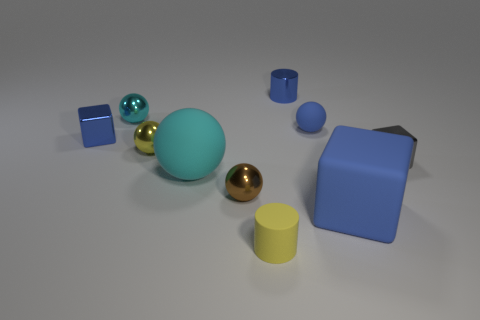There is a cyan thing in front of the tiny metal block left of the blue matte sphere behind the small brown ball; what is its size?
Your response must be concise. Large. What size is the rubber block that is the same color as the metal cylinder?
Give a very brief answer. Large. What is the material of the sphere that is the same color as the big block?
Your response must be concise. Rubber. Do the large rubber object that is behind the large blue matte block and the tiny metal ball behind the yellow ball have the same color?
Your answer should be compact. Yes. There is a cyan shiny thing on the left side of the big rubber thing that is on the right side of the tiny cylinder behind the large blue matte thing; what shape is it?
Offer a very short reply. Sphere. What shape is the blue thing that is both to the left of the tiny blue ball and right of the cyan metallic object?
Provide a short and direct response. Cylinder. What number of small yellow metallic things are in front of the tiny block that is to the right of the cylinder behind the cyan rubber sphere?
Provide a succinct answer. 0. There is a brown object that is the same shape as the small cyan metal thing; what size is it?
Provide a short and direct response. Small. Is the material of the tiny cylinder that is to the left of the blue metal cylinder the same as the tiny cyan thing?
Your response must be concise. No. There is a tiny shiny object that is the same shape as the small yellow rubber thing; what is its color?
Provide a short and direct response. Blue. 